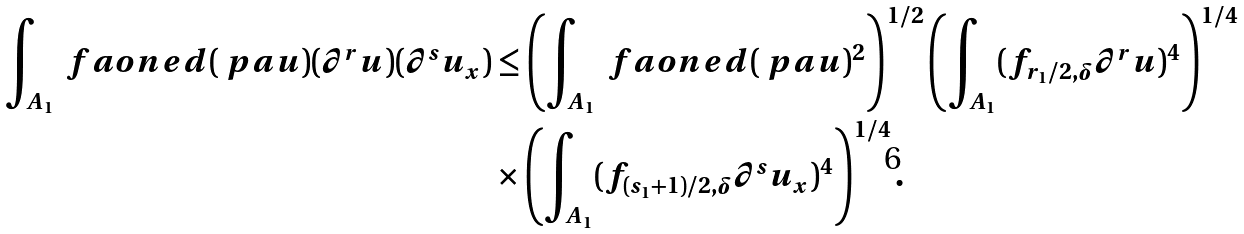Convert formula to latex. <formula><loc_0><loc_0><loc_500><loc_500>\int _ { A _ { 1 } } \ f a o n e d ( \ p a u ) ( \partial ^ { r } u ) ( \partial ^ { s } u _ { x } ) & \leq \left ( \int _ { A _ { 1 } } \ f a o n e d ( \ p a u ) ^ { 2 } \right ) ^ { 1 / 2 } \left ( \int _ { A _ { 1 } } ( f _ { r _ { 1 } / 2 , \delta } \partial ^ { r } u ) ^ { 4 } \right ) ^ { 1 / 4 } \\ & \times \left ( \int _ { A _ { 1 } } ( f _ { ( s _ { 1 } + 1 ) / 2 , \delta } \partial ^ { s } u _ { x } ) ^ { 4 } \right ) ^ { 1 / 4 } .</formula> 